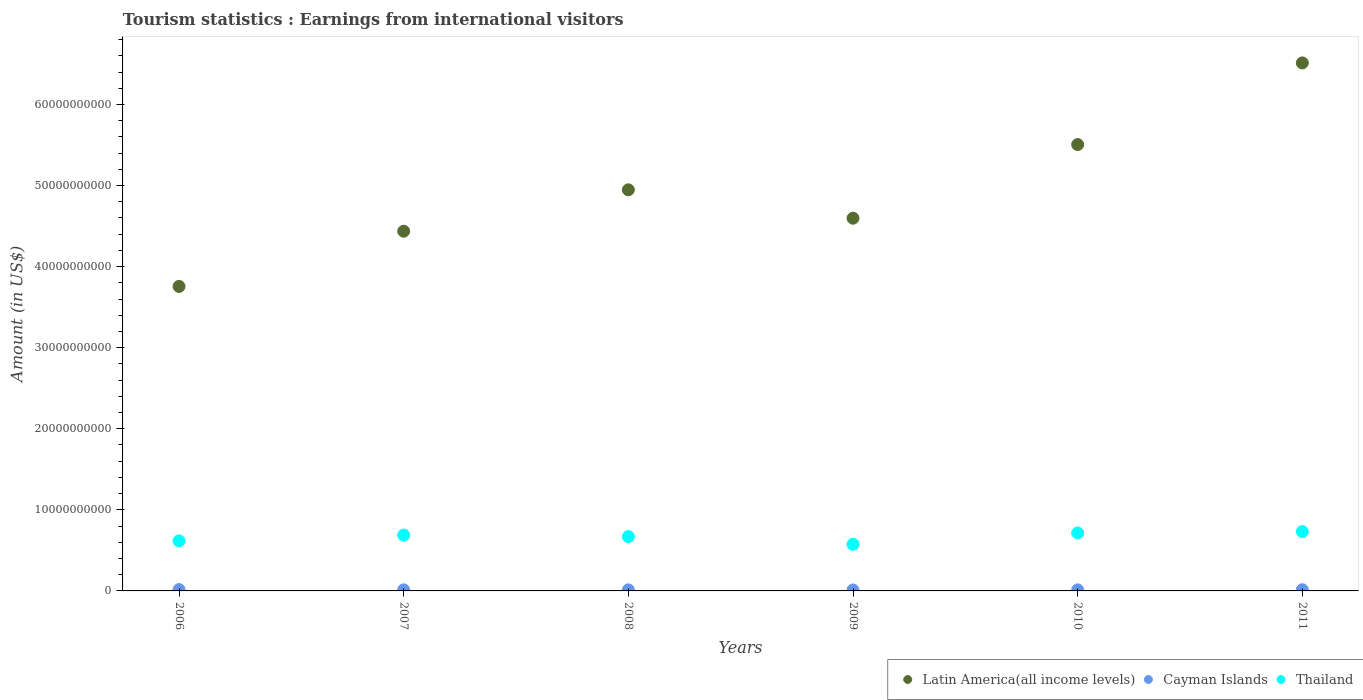How many different coloured dotlines are there?
Your response must be concise. 3. Is the number of dotlines equal to the number of legend labels?
Offer a terse response. Yes. What is the earnings from international visitors in Cayman Islands in 2006?
Your answer should be very brief. 1.64e+08. Across all years, what is the maximum earnings from international visitors in Thailand?
Your answer should be very brief. 7.32e+09. Across all years, what is the minimum earnings from international visitors in Cayman Islands?
Give a very brief answer. 1.20e+08. In which year was the earnings from international visitors in Latin America(all income levels) maximum?
Your response must be concise. 2011. What is the total earnings from international visitors in Thailand in the graph?
Give a very brief answer. 4.00e+1. What is the difference between the earnings from international visitors in Latin America(all income levels) in 2007 and that in 2011?
Give a very brief answer. -2.08e+1. What is the difference between the earnings from international visitors in Thailand in 2011 and the earnings from international visitors in Latin America(all income levels) in 2008?
Give a very brief answer. -4.22e+1. What is the average earnings from international visitors in Thailand per year?
Make the answer very short. 6.66e+09. In the year 2011, what is the difference between the earnings from international visitors in Cayman Islands and earnings from international visitors in Latin America(all income levels)?
Your response must be concise. -6.50e+1. In how many years, is the earnings from international visitors in Latin America(all income levels) greater than 4000000000 US$?
Make the answer very short. 6. What is the ratio of the earnings from international visitors in Thailand in 2010 to that in 2011?
Your answer should be compact. 0.98. Is the earnings from international visitors in Latin America(all income levels) in 2010 less than that in 2011?
Your response must be concise. Yes. What is the difference between the highest and the second highest earnings from international visitors in Thailand?
Offer a terse response. 1.69e+08. What is the difference between the highest and the lowest earnings from international visitors in Thailand?
Your answer should be compact. 1.57e+09. In how many years, is the earnings from international visitors in Thailand greater than the average earnings from international visitors in Thailand taken over all years?
Your response must be concise. 4. Is it the case that in every year, the sum of the earnings from international visitors in Thailand and earnings from international visitors in Latin America(all income levels)  is greater than the earnings from international visitors in Cayman Islands?
Make the answer very short. Yes. Is the earnings from international visitors in Cayman Islands strictly less than the earnings from international visitors in Thailand over the years?
Offer a very short reply. Yes. How many dotlines are there?
Ensure brevity in your answer.  3. How many years are there in the graph?
Your answer should be very brief. 6. What is the difference between two consecutive major ticks on the Y-axis?
Your answer should be very brief. 1.00e+1. Are the values on the major ticks of Y-axis written in scientific E-notation?
Offer a very short reply. No. Does the graph contain grids?
Ensure brevity in your answer.  No. Where does the legend appear in the graph?
Offer a terse response. Bottom right. How many legend labels are there?
Keep it short and to the point. 3. How are the legend labels stacked?
Your answer should be compact. Horizontal. What is the title of the graph?
Offer a very short reply. Tourism statistics : Earnings from international visitors. Does "Costa Rica" appear as one of the legend labels in the graph?
Make the answer very short. No. What is the label or title of the X-axis?
Your answer should be very brief. Years. What is the label or title of the Y-axis?
Offer a very short reply. Amount (in US$). What is the Amount (in US$) of Latin America(all income levels) in 2006?
Provide a succinct answer. 3.76e+1. What is the Amount (in US$) in Cayman Islands in 2006?
Give a very brief answer. 1.64e+08. What is the Amount (in US$) of Thailand in 2006?
Provide a short and direct response. 6.17e+09. What is the Amount (in US$) in Latin America(all income levels) in 2007?
Offer a very short reply. 4.44e+1. What is the Amount (in US$) of Cayman Islands in 2007?
Make the answer very short. 1.32e+08. What is the Amount (in US$) of Thailand in 2007?
Your answer should be compact. 6.89e+09. What is the Amount (in US$) of Latin America(all income levels) in 2008?
Your answer should be very brief. 4.95e+1. What is the Amount (in US$) in Cayman Islands in 2008?
Your answer should be compact. 1.30e+08. What is the Amount (in US$) of Thailand in 2008?
Offer a terse response. 6.70e+09. What is the Amount (in US$) of Latin America(all income levels) in 2009?
Ensure brevity in your answer.  4.60e+1. What is the Amount (in US$) of Cayman Islands in 2009?
Give a very brief answer. 1.20e+08. What is the Amount (in US$) in Thailand in 2009?
Provide a succinct answer. 5.75e+09. What is the Amount (in US$) of Latin America(all income levels) in 2010?
Give a very brief answer. 5.51e+1. What is the Amount (in US$) in Cayman Islands in 2010?
Make the answer very short. 1.29e+08. What is the Amount (in US$) in Thailand in 2010?
Keep it short and to the point. 7.15e+09. What is the Amount (in US$) in Latin America(all income levels) in 2011?
Offer a very short reply. 6.51e+1. What is the Amount (in US$) of Cayman Islands in 2011?
Give a very brief answer. 1.45e+08. What is the Amount (in US$) of Thailand in 2011?
Your answer should be very brief. 7.32e+09. Across all years, what is the maximum Amount (in US$) of Latin America(all income levels)?
Your answer should be very brief. 6.51e+1. Across all years, what is the maximum Amount (in US$) in Cayman Islands?
Offer a terse response. 1.64e+08. Across all years, what is the maximum Amount (in US$) of Thailand?
Your response must be concise. 7.32e+09. Across all years, what is the minimum Amount (in US$) in Latin America(all income levels)?
Offer a very short reply. 3.76e+1. Across all years, what is the minimum Amount (in US$) in Cayman Islands?
Offer a terse response. 1.20e+08. Across all years, what is the minimum Amount (in US$) of Thailand?
Your answer should be compact. 5.75e+09. What is the total Amount (in US$) in Latin America(all income levels) in the graph?
Offer a terse response. 2.98e+11. What is the total Amount (in US$) of Cayman Islands in the graph?
Provide a short and direct response. 8.20e+08. What is the total Amount (in US$) in Thailand in the graph?
Your answer should be compact. 4.00e+1. What is the difference between the Amount (in US$) in Latin America(all income levels) in 2006 and that in 2007?
Provide a succinct answer. -6.81e+09. What is the difference between the Amount (in US$) in Cayman Islands in 2006 and that in 2007?
Keep it short and to the point. 3.20e+07. What is the difference between the Amount (in US$) of Thailand in 2006 and that in 2007?
Keep it short and to the point. -7.14e+08. What is the difference between the Amount (in US$) in Latin America(all income levels) in 2006 and that in 2008?
Your answer should be compact. -1.19e+1. What is the difference between the Amount (in US$) in Cayman Islands in 2006 and that in 2008?
Make the answer very short. 3.40e+07. What is the difference between the Amount (in US$) of Thailand in 2006 and that in 2008?
Your answer should be very brief. -5.27e+08. What is the difference between the Amount (in US$) in Latin America(all income levels) in 2006 and that in 2009?
Offer a terse response. -8.42e+09. What is the difference between the Amount (in US$) of Cayman Islands in 2006 and that in 2009?
Ensure brevity in your answer.  4.40e+07. What is the difference between the Amount (in US$) of Thailand in 2006 and that in 2009?
Make the answer very short. 4.24e+08. What is the difference between the Amount (in US$) of Latin America(all income levels) in 2006 and that in 2010?
Your answer should be compact. -1.75e+1. What is the difference between the Amount (in US$) in Cayman Islands in 2006 and that in 2010?
Ensure brevity in your answer.  3.50e+07. What is the difference between the Amount (in US$) of Thailand in 2006 and that in 2010?
Provide a short and direct response. -9.78e+08. What is the difference between the Amount (in US$) of Latin America(all income levels) in 2006 and that in 2011?
Your answer should be compact. -2.76e+1. What is the difference between the Amount (in US$) in Cayman Islands in 2006 and that in 2011?
Offer a very short reply. 1.90e+07. What is the difference between the Amount (in US$) of Thailand in 2006 and that in 2011?
Your response must be concise. -1.15e+09. What is the difference between the Amount (in US$) in Latin America(all income levels) in 2007 and that in 2008?
Offer a very short reply. -5.10e+09. What is the difference between the Amount (in US$) in Thailand in 2007 and that in 2008?
Ensure brevity in your answer.  1.87e+08. What is the difference between the Amount (in US$) of Latin America(all income levels) in 2007 and that in 2009?
Provide a succinct answer. -1.60e+09. What is the difference between the Amount (in US$) in Thailand in 2007 and that in 2009?
Offer a terse response. 1.14e+09. What is the difference between the Amount (in US$) in Latin America(all income levels) in 2007 and that in 2010?
Keep it short and to the point. -1.07e+1. What is the difference between the Amount (in US$) of Thailand in 2007 and that in 2010?
Keep it short and to the point. -2.64e+08. What is the difference between the Amount (in US$) in Latin America(all income levels) in 2007 and that in 2011?
Give a very brief answer. -2.08e+1. What is the difference between the Amount (in US$) of Cayman Islands in 2007 and that in 2011?
Keep it short and to the point. -1.30e+07. What is the difference between the Amount (in US$) of Thailand in 2007 and that in 2011?
Give a very brief answer. -4.33e+08. What is the difference between the Amount (in US$) in Latin America(all income levels) in 2008 and that in 2009?
Your answer should be compact. 3.50e+09. What is the difference between the Amount (in US$) of Cayman Islands in 2008 and that in 2009?
Ensure brevity in your answer.  1.00e+07. What is the difference between the Amount (in US$) of Thailand in 2008 and that in 2009?
Give a very brief answer. 9.51e+08. What is the difference between the Amount (in US$) in Latin America(all income levels) in 2008 and that in 2010?
Offer a terse response. -5.58e+09. What is the difference between the Amount (in US$) of Cayman Islands in 2008 and that in 2010?
Ensure brevity in your answer.  1.00e+06. What is the difference between the Amount (in US$) of Thailand in 2008 and that in 2010?
Ensure brevity in your answer.  -4.51e+08. What is the difference between the Amount (in US$) of Latin America(all income levels) in 2008 and that in 2011?
Give a very brief answer. -1.57e+1. What is the difference between the Amount (in US$) of Cayman Islands in 2008 and that in 2011?
Your answer should be compact. -1.50e+07. What is the difference between the Amount (in US$) in Thailand in 2008 and that in 2011?
Give a very brief answer. -6.20e+08. What is the difference between the Amount (in US$) in Latin America(all income levels) in 2009 and that in 2010?
Provide a succinct answer. -9.08e+09. What is the difference between the Amount (in US$) of Cayman Islands in 2009 and that in 2010?
Ensure brevity in your answer.  -9.00e+06. What is the difference between the Amount (in US$) in Thailand in 2009 and that in 2010?
Keep it short and to the point. -1.40e+09. What is the difference between the Amount (in US$) of Latin America(all income levels) in 2009 and that in 2011?
Give a very brief answer. -1.92e+1. What is the difference between the Amount (in US$) of Cayman Islands in 2009 and that in 2011?
Offer a terse response. -2.50e+07. What is the difference between the Amount (in US$) of Thailand in 2009 and that in 2011?
Make the answer very short. -1.57e+09. What is the difference between the Amount (in US$) in Latin America(all income levels) in 2010 and that in 2011?
Provide a short and direct response. -1.01e+1. What is the difference between the Amount (in US$) in Cayman Islands in 2010 and that in 2011?
Provide a succinct answer. -1.60e+07. What is the difference between the Amount (in US$) of Thailand in 2010 and that in 2011?
Offer a terse response. -1.69e+08. What is the difference between the Amount (in US$) of Latin America(all income levels) in 2006 and the Amount (in US$) of Cayman Islands in 2007?
Provide a succinct answer. 3.74e+1. What is the difference between the Amount (in US$) in Latin America(all income levels) in 2006 and the Amount (in US$) in Thailand in 2007?
Offer a very short reply. 3.07e+1. What is the difference between the Amount (in US$) in Cayman Islands in 2006 and the Amount (in US$) in Thailand in 2007?
Give a very brief answer. -6.72e+09. What is the difference between the Amount (in US$) in Latin America(all income levels) in 2006 and the Amount (in US$) in Cayman Islands in 2008?
Provide a succinct answer. 3.74e+1. What is the difference between the Amount (in US$) of Latin America(all income levels) in 2006 and the Amount (in US$) of Thailand in 2008?
Keep it short and to the point. 3.09e+1. What is the difference between the Amount (in US$) of Cayman Islands in 2006 and the Amount (in US$) of Thailand in 2008?
Provide a short and direct response. -6.54e+09. What is the difference between the Amount (in US$) of Latin America(all income levels) in 2006 and the Amount (in US$) of Cayman Islands in 2009?
Your response must be concise. 3.74e+1. What is the difference between the Amount (in US$) of Latin America(all income levels) in 2006 and the Amount (in US$) of Thailand in 2009?
Your answer should be very brief. 3.18e+1. What is the difference between the Amount (in US$) in Cayman Islands in 2006 and the Amount (in US$) in Thailand in 2009?
Provide a short and direct response. -5.58e+09. What is the difference between the Amount (in US$) in Latin America(all income levels) in 2006 and the Amount (in US$) in Cayman Islands in 2010?
Make the answer very short. 3.74e+1. What is the difference between the Amount (in US$) in Latin America(all income levels) in 2006 and the Amount (in US$) in Thailand in 2010?
Provide a short and direct response. 3.04e+1. What is the difference between the Amount (in US$) in Cayman Islands in 2006 and the Amount (in US$) in Thailand in 2010?
Ensure brevity in your answer.  -6.99e+09. What is the difference between the Amount (in US$) in Latin America(all income levels) in 2006 and the Amount (in US$) in Cayman Islands in 2011?
Your answer should be compact. 3.74e+1. What is the difference between the Amount (in US$) of Latin America(all income levels) in 2006 and the Amount (in US$) of Thailand in 2011?
Make the answer very short. 3.02e+1. What is the difference between the Amount (in US$) of Cayman Islands in 2006 and the Amount (in US$) of Thailand in 2011?
Your answer should be very brief. -7.16e+09. What is the difference between the Amount (in US$) of Latin America(all income levels) in 2007 and the Amount (in US$) of Cayman Islands in 2008?
Your answer should be compact. 4.42e+1. What is the difference between the Amount (in US$) of Latin America(all income levels) in 2007 and the Amount (in US$) of Thailand in 2008?
Make the answer very short. 3.77e+1. What is the difference between the Amount (in US$) in Cayman Islands in 2007 and the Amount (in US$) in Thailand in 2008?
Your response must be concise. -6.57e+09. What is the difference between the Amount (in US$) of Latin America(all income levels) in 2007 and the Amount (in US$) of Cayman Islands in 2009?
Your answer should be compact. 4.43e+1. What is the difference between the Amount (in US$) in Latin America(all income levels) in 2007 and the Amount (in US$) in Thailand in 2009?
Ensure brevity in your answer.  3.86e+1. What is the difference between the Amount (in US$) in Cayman Islands in 2007 and the Amount (in US$) in Thailand in 2009?
Your response must be concise. -5.62e+09. What is the difference between the Amount (in US$) in Latin America(all income levels) in 2007 and the Amount (in US$) in Cayman Islands in 2010?
Provide a short and direct response. 4.42e+1. What is the difference between the Amount (in US$) of Latin America(all income levels) in 2007 and the Amount (in US$) of Thailand in 2010?
Keep it short and to the point. 3.72e+1. What is the difference between the Amount (in US$) in Cayman Islands in 2007 and the Amount (in US$) in Thailand in 2010?
Keep it short and to the point. -7.02e+09. What is the difference between the Amount (in US$) in Latin America(all income levels) in 2007 and the Amount (in US$) in Cayman Islands in 2011?
Give a very brief answer. 4.42e+1. What is the difference between the Amount (in US$) of Latin America(all income levels) in 2007 and the Amount (in US$) of Thailand in 2011?
Offer a very short reply. 3.71e+1. What is the difference between the Amount (in US$) in Cayman Islands in 2007 and the Amount (in US$) in Thailand in 2011?
Your answer should be very brief. -7.19e+09. What is the difference between the Amount (in US$) in Latin America(all income levels) in 2008 and the Amount (in US$) in Cayman Islands in 2009?
Your answer should be compact. 4.94e+1. What is the difference between the Amount (in US$) in Latin America(all income levels) in 2008 and the Amount (in US$) in Thailand in 2009?
Your response must be concise. 4.37e+1. What is the difference between the Amount (in US$) of Cayman Islands in 2008 and the Amount (in US$) of Thailand in 2009?
Your response must be concise. -5.62e+09. What is the difference between the Amount (in US$) in Latin America(all income levels) in 2008 and the Amount (in US$) in Cayman Islands in 2010?
Make the answer very short. 4.93e+1. What is the difference between the Amount (in US$) in Latin America(all income levels) in 2008 and the Amount (in US$) in Thailand in 2010?
Give a very brief answer. 4.23e+1. What is the difference between the Amount (in US$) in Cayman Islands in 2008 and the Amount (in US$) in Thailand in 2010?
Offer a terse response. -7.02e+09. What is the difference between the Amount (in US$) of Latin America(all income levels) in 2008 and the Amount (in US$) of Cayman Islands in 2011?
Your answer should be very brief. 4.93e+1. What is the difference between the Amount (in US$) in Latin America(all income levels) in 2008 and the Amount (in US$) in Thailand in 2011?
Ensure brevity in your answer.  4.22e+1. What is the difference between the Amount (in US$) in Cayman Islands in 2008 and the Amount (in US$) in Thailand in 2011?
Make the answer very short. -7.19e+09. What is the difference between the Amount (in US$) in Latin America(all income levels) in 2009 and the Amount (in US$) in Cayman Islands in 2010?
Keep it short and to the point. 4.58e+1. What is the difference between the Amount (in US$) in Latin America(all income levels) in 2009 and the Amount (in US$) in Thailand in 2010?
Your answer should be very brief. 3.88e+1. What is the difference between the Amount (in US$) of Cayman Islands in 2009 and the Amount (in US$) of Thailand in 2010?
Your answer should be compact. -7.03e+09. What is the difference between the Amount (in US$) in Latin America(all income levels) in 2009 and the Amount (in US$) in Cayman Islands in 2011?
Your response must be concise. 4.58e+1. What is the difference between the Amount (in US$) in Latin America(all income levels) in 2009 and the Amount (in US$) in Thailand in 2011?
Keep it short and to the point. 3.87e+1. What is the difference between the Amount (in US$) in Cayman Islands in 2009 and the Amount (in US$) in Thailand in 2011?
Offer a very short reply. -7.20e+09. What is the difference between the Amount (in US$) in Latin America(all income levels) in 2010 and the Amount (in US$) in Cayman Islands in 2011?
Give a very brief answer. 5.49e+1. What is the difference between the Amount (in US$) in Latin America(all income levels) in 2010 and the Amount (in US$) in Thailand in 2011?
Provide a short and direct response. 4.77e+1. What is the difference between the Amount (in US$) in Cayman Islands in 2010 and the Amount (in US$) in Thailand in 2011?
Make the answer very short. -7.19e+09. What is the average Amount (in US$) in Latin America(all income levels) per year?
Offer a very short reply. 4.96e+1. What is the average Amount (in US$) of Cayman Islands per year?
Your response must be concise. 1.37e+08. What is the average Amount (in US$) of Thailand per year?
Make the answer very short. 6.66e+09. In the year 2006, what is the difference between the Amount (in US$) of Latin America(all income levels) and Amount (in US$) of Cayman Islands?
Provide a short and direct response. 3.74e+1. In the year 2006, what is the difference between the Amount (in US$) of Latin America(all income levels) and Amount (in US$) of Thailand?
Offer a very short reply. 3.14e+1. In the year 2006, what is the difference between the Amount (in US$) of Cayman Islands and Amount (in US$) of Thailand?
Your answer should be compact. -6.01e+09. In the year 2007, what is the difference between the Amount (in US$) in Latin America(all income levels) and Amount (in US$) in Cayman Islands?
Offer a terse response. 4.42e+1. In the year 2007, what is the difference between the Amount (in US$) of Latin America(all income levels) and Amount (in US$) of Thailand?
Make the answer very short. 3.75e+1. In the year 2007, what is the difference between the Amount (in US$) in Cayman Islands and Amount (in US$) in Thailand?
Make the answer very short. -6.76e+09. In the year 2008, what is the difference between the Amount (in US$) in Latin America(all income levels) and Amount (in US$) in Cayman Islands?
Your answer should be compact. 4.93e+1. In the year 2008, what is the difference between the Amount (in US$) of Latin America(all income levels) and Amount (in US$) of Thailand?
Provide a succinct answer. 4.28e+1. In the year 2008, what is the difference between the Amount (in US$) of Cayman Islands and Amount (in US$) of Thailand?
Make the answer very short. -6.57e+09. In the year 2009, what is the difference between the Amount (in US$) of Latin America(all income levels) and Amount (in US$) of Cayman Islands?
Keep it short and to the point. 4.59e+1. In the year 2009, what is the difference between the Amount (in US$) in Latin America(all income levels) and Amount (in US$) in Thailand?
Ensure brevity in your answer.  4.02e+1. In the year 2009, what is the difference between the Amount (in US$) of Cayman Islands and Amount (in US$) of Thailand?
Give a very brief answer. -5.63e+09. In the year 2010, what is the difference between the Amount (in US$) in Latin America(all income levels) and Amount (in US$) in Cayman Islands?
Make the answer very short. 5.49e+1. In the year 2010, what is the difference between the Amount (in US$) of Latin America(all income levels) and Amount (in US$) of Thailand?
Provide a succinct answer. 4.79e+1. In the year 2010, what is the difference between the Amount (in US$) in Cayman Islands and Amount (in US$) in Thailand?
Provide a short and direct response. -7.02e+09. In the year 2011, what is the difference between the Amount (in US$) of Latin America(all income levels) and Amount (in US$) of Cayman Islands?
Make the answer very short. 6.50e+1. In the year 2011, what is the difference between the Amount (in US$) in Latin America(all income levels) and Amount (in US$) in Thailand?
Your answer should be very brief. 5.78e+1. In the year 2011, what is the difference between the Amount (in US$) in Cayman Islands and Amount (in US$) in Thailand?
Ensure brevity in your answer.  -7.18e+09. What is the ratio of the Amount (in US$) in Latin America(all income levels) in 2006 to that in 2007?
Offer a very short reply. 0.85. What is the ratio of the Amount (in US$) of Cayman Islands in 2006 to that in 2007?
Offer a terse response. 1.24. What is the ratio of the Amount (in US$) of Thailand in 2006 to that in 2007?
Offer a very short reply. 0.9. What is the ratio of the Amount (in US$) of Latin America(all income levels) in 2006 to that in 2008?
Make the answer very short. 0.76. What is the ratio of the Amount (in US$) in Cayman Islands in 2006 to that in 2008?
Provide a short and direct response. 1.26. What is the ratio of the Amount (in US$) of Thailand in 2006 to that in 2008?
Ensure brevity in your answer.  0.92. What is the ratio of the Amount (in US$) in Latin America(all income levels) in 2006 to that in 2009?
Offer a very short reply. 0.82. What is the ratio of the Amount (in US$) in Cayman Islands in 2006 to that in 2009?
Give a very brief answer. 1.37. What is the ratio of the Amount (in US$) in Thailand in 2006 to that in 2009?
Your answer should be compact. 1.07. What is the ratio of the Amount (in US$) in Latin America(all income levels) in 2006 to that in 2010?
Provide a short and direct response. 0.68. What is the ratio of the Amount (in US$) of Cayman Islands in 2006 to that in 2010?
Your answer should be compact. 1.27. What is the ratio of the Amount (in US$) of Thailand in 2006 to that in 2010?
Your answer should be compact. 0.86. What is the ratio of the Amount (in US$) in Latin America(all income levels) in 2006 to that in 2011?
Your response must be concise. 0.58. What is the ratio of the Amount (in US$) of Cayman Islands in 2006 to that in 2011?
Give a very brief answer. 1.13. What is the ratio of the Amount (in US$) in Thailand in 2006 to that in 2011?
Offer a very short reply. 0.84. What is the ratio of the Amount (in US$) of Latin America(all income levels) in 2007 to that in 2008?
Your answer should be compact. 0.9. What is the ratio of the Amount (in US$) of Cayman Islands in 2007 to that in 2008?
Your response must be concise. 1.02. What is the ratio of the Amount (in US$) of Thailand in 2007 to that in 2008?
Provide a succinct answer. 1.03. What is the ratio of the Amount (in US$) in Latin America(all income levels) in 2007 to that in 2009?
Make the answer very short. 0.97. What is the ratio of the Amount (in US$) of Thailand in 2007 to that in 2009?
Offer a very short reply. 1.2. What is the ratio of the Amount (in US$) in Latin America(all income levels) in 2007 to that in 2010?
Your answer should be compact. 0.81. What is the ratio of the Amount (in US$) of Cayman Islands in 2007 to that in 2010?
Your response must be concise. 1.02. What is the ratio of the Amount (in US$) in Thailand in 2007 to that in 2010?
Your answer should be very brief. 0.96. What is the ratio of the Amount (in US$) of Latin America(all income levels) in 2007 to that in 2011?
Your response must be concise. 0.68. What is the ratio of the Amount (in US$) of Cayman Islands in 2007 to that in 2011?
Offer a very short reply. 0.91. What is the ratio of the Amount (in US$) of Thailand in 2007 to that in 2011?
Your answer should be very brief. 0.94. What is the ratio of the Amount (in US$) in Latin America(all income levels) in 2008 to that in 2009?
Offer a very short reply. 1.08. What is the ratio of the Amount (in US$) of Cayman Islands in 2008 to that in 2009?
Give a very brief answer. 1.08. What is the ratio of the Amount (in US$) of Thailand in 2008 to that in 2009?
Offer a terse response. 1.17. What is the ratio of the Amount (in US$) of Latin America(all income levels) in 2008 to that in 2010?
Provide a short and direct response. 0.9. What is the ratio of the Amount (in US$) in Thailand in 2008 to that in 2010?
Offer a terse response. 0.94. What is the ratio of the Amount (in US$) of Latin America(all income levels) in 2008 to that in 2011?
Make the answer very short. 0.76. What is the ratio of the Amount (in US$) of Cayman Islands in 2008 to that in 2011?
Your answer should be very brief. 0.9. What is the ratio of the Amount (in US$) in Thailand in 2008 to that in 2011?
Give a very brief answer. 0.92. What is the ratio of the Amount (in US$) in Latin America(all income levels) in 2009 to that in 2010?
Your answer should be compact. 0.83. What is the ratio of the Amount (in US$) of Cayman Islands in 2009 to that in 2010?
Provide a succinct answer. 0.93. What is the ratio of the Amount (in US$) in Thailand in 2009 to that in 2010?
Keep it short and to the point. 0.8. What is the ratio of the Amount (in US$) of Latin America(all income levels) in 2009 to that in 2011?
Give a very brief answer. 0.71. What is the ratio of the Amount (in US$) of Cayman Islands in 2009 to that in 2011?
Provide a short and direct response. 0.83. What is the ratio of the Amount (in US$) in Thailand in 2009 to that in 2011?
Provide a succinct answer. 0.79. What is the ratio of the Amount (in US$) in Latin America(all income levels) in 2010 to that in 2011?
Keep it short and to the point. 0.85. What is the ratio of the Amount (in US$) in Cayman Islands in 2010 to that in 2011?
Provide a short and direct response. 0.89. What is the ratio of the Amount (in US$) in Thailand in 2010 to that in 2011?
Offer a terse response. 0.98. What is the difference between the highest and the second highest Amount (in US$) of Latin America(all income levels)?
Offer a terse response. 1.01e+1. What is the difference between the highest and the second highest Amount (in US$) of Cayman Islands?
Keep it short and to the point. 1.90e+07. What is the difference between the highest and the second highest Amount (in US$) in Thailand?
Your answer should be very brief. 1.69e+08. What is the difference between the highest and the lowest Amount (in US$) of Latin America(all income levels)?
Provide a short and direct response. 2.76e+1. What is the difference between the highest and the lowest Amount (in US$) in Cayman Islands?
Make the answer very short. 4.40e+07. What is the difference between the highest and the lowest Amount (in US$) in Thailand?
Ensure brevity in your answer.  1.57e+09. 